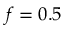<formula> <loc_0><loc_0><loc_500><loc_500>f = 0 . 5</formula> 